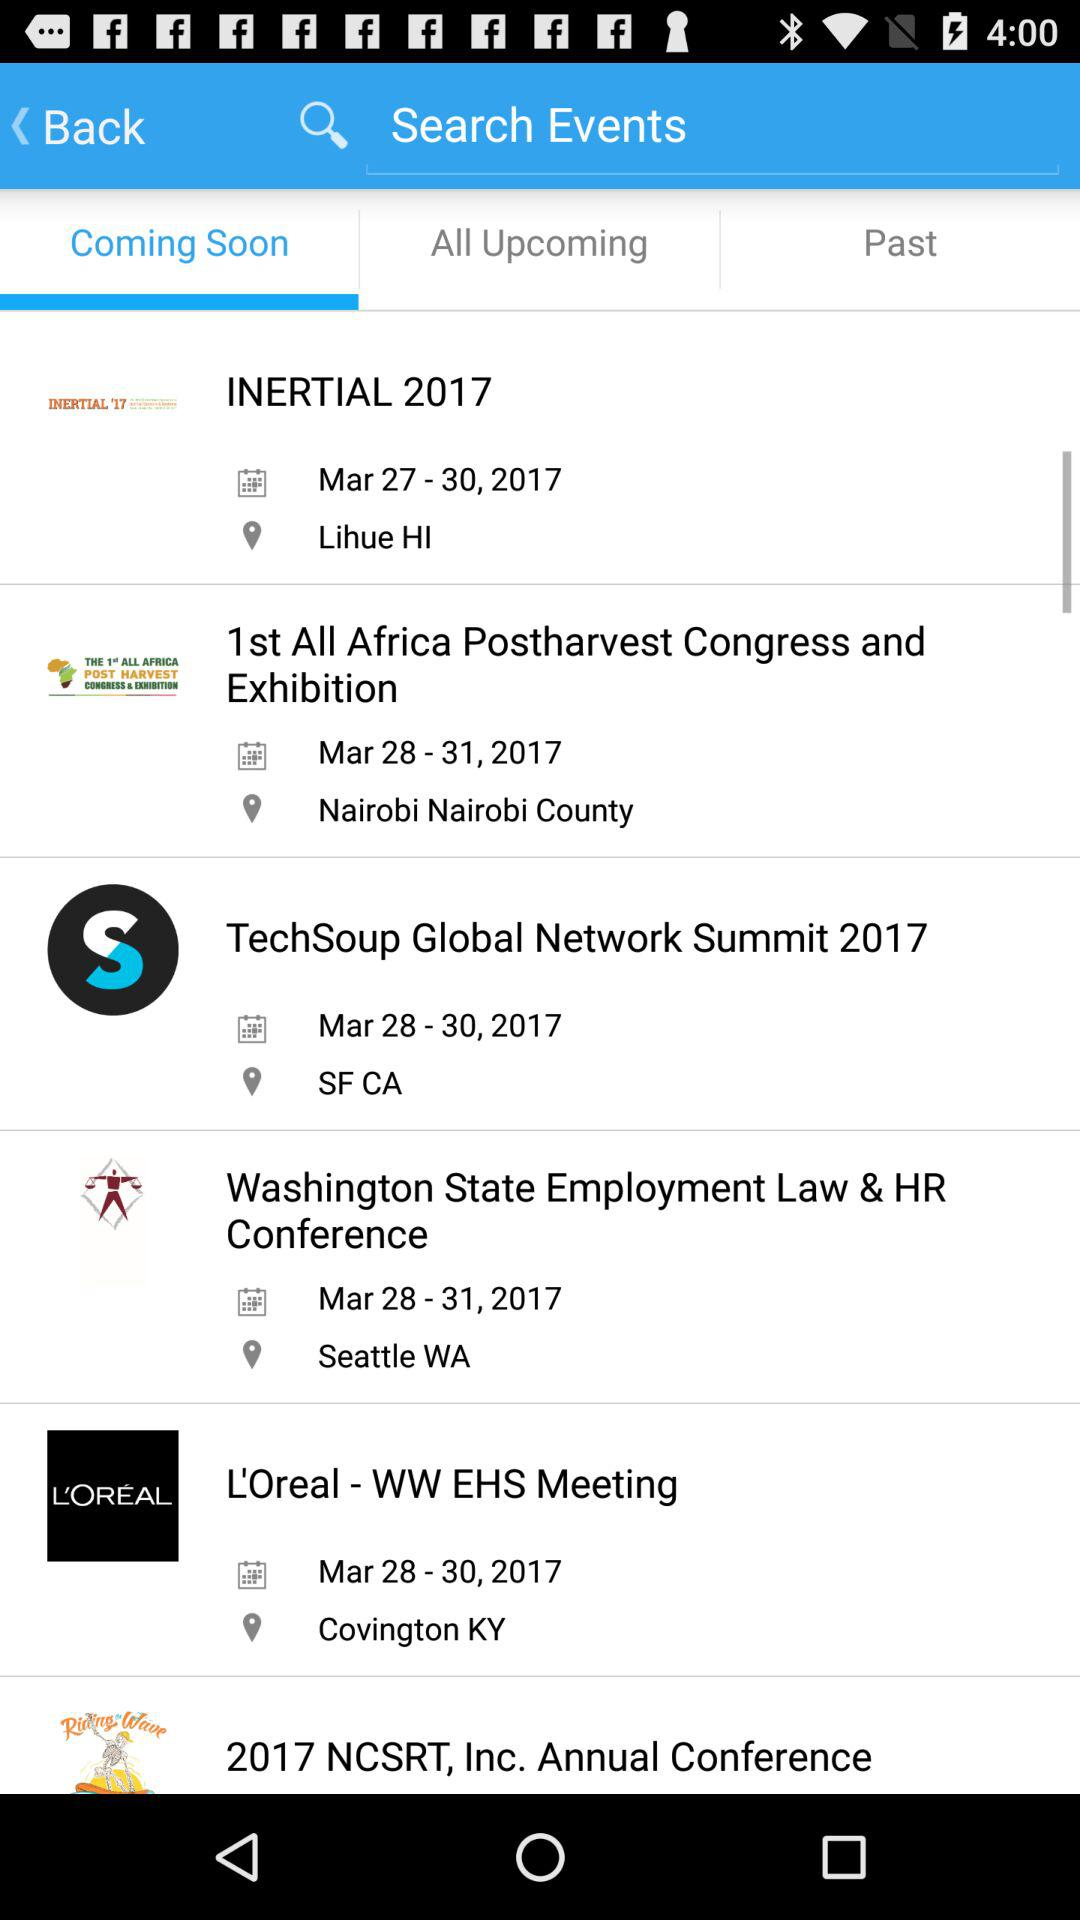What is the date range of "Techsoup Global Network Summit 2017" event? The date range is from March 28 to March 30, 2017. 